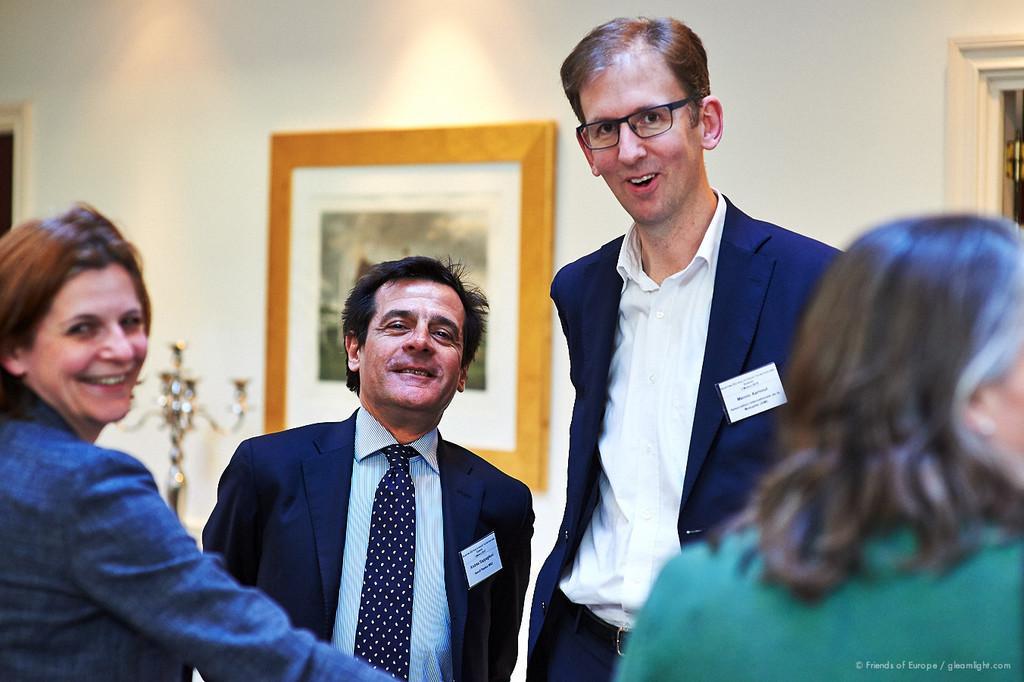Describe this image in one or two sentences. In this image, in the middle there is a man, he wears a suit, shirt, tie and there is a man, he wears a suit, shirt, trouser. On the right there is a woman. On the left there is a woman. In the background there are photo frames, lights and a wall. 